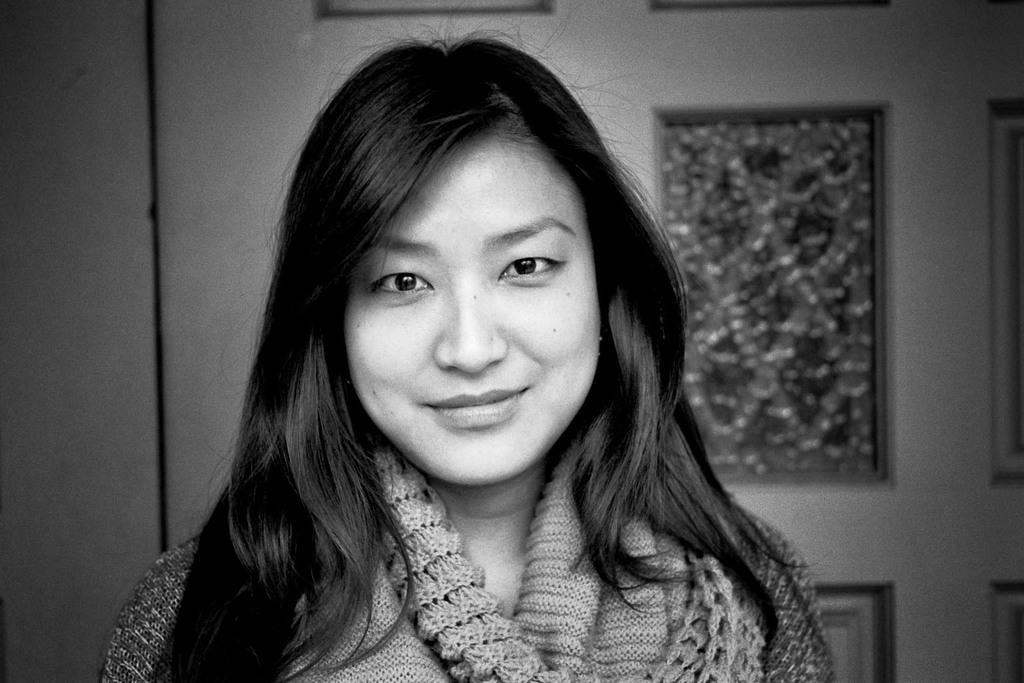Who is the main subject in the image? There is a lady in the center of the image. What is the lady doing in the image? The lady is smiling. What can be seen in the background of the image? There is a wall and a door in the background of the image. What type of stocking is the lady wearing in the image? There is no mention of stockings or any clothing details in the image, so it cannot be determined from the image. 